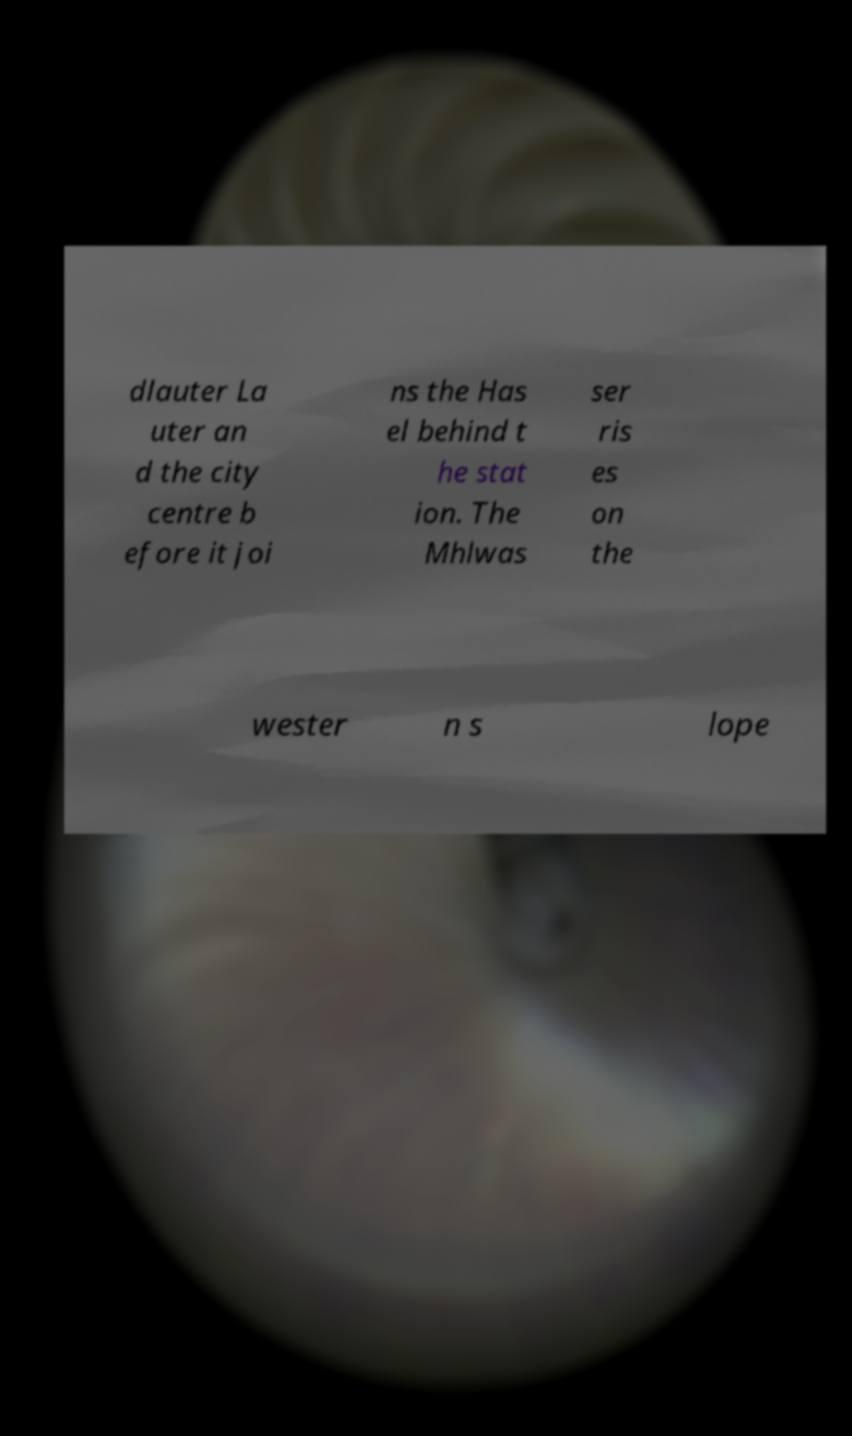Can you accurately transcribe the text from the provided image for me? dlauter La uter an d the city centre b efore it joi ns the Has el behind t he stat ion. The Mhlwas ser ris es on the wester n s lope 